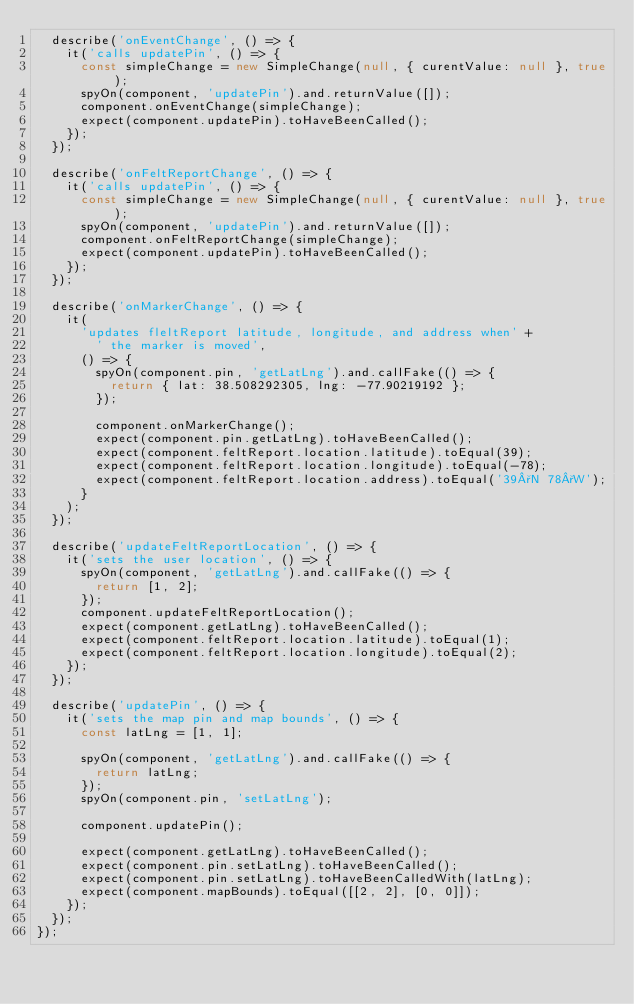Convert code to text. <code><loc_0><loc_0><loc_500><loc_500><_TypeScript_>  describe('onEventChange', () => {
    it('calls updatePin', () => {
      const simpleChange = new SimpleChange(null, { curentValue: null }, true);
      spyOn(component, 'updatePin').and.returnValue([]);
      component.onEventChange(simpleChange);
      expect(component.updatePin).toHaveBeenCalled();
    });
  });

  describe('onFeltReportChange', () => {
    it('calls updatePin', () => {
      const simpleChange = new SimpleChange(null, { curentValue: null }, true);
      spyOn(component, 'updatePin').and.returnValue([]);
      component.onFeltReportChange(simpleChange);
      expect(component.updatePin).toHaveBeenCalled();
    });
  });

  describe('onMarkerChange', () => {
    it(
      'updates fleltReport latitude, longitude, and address when' +
        ' the marker is moved',
      () => {
        spyOn(component.pin, 'getLatLng').and.callFake(() => {
          return { lat: 38.508292305, lng: -77.90219192 };
        });

        component.onMarkerChange();
        expect(component.pin.getLatLng).toHaveBeenCalled();
        expect(component.feltReport.location.latitude).toEqual(39);
        expect(component.feltReport.location.longitude).toEqual(-78);
        expect(component.feltReport.location.address).toEqual('39°N 78°W');
      }
    );
  });

  describe('updateFeltReportLocation', () => {
    it('sets the user location', () => {
      spyOn(component, 'getLatLng').and.callFake(() => {
        return [1, 2];
      });
      component.updateFeltReportLocation();
      expect(component.getLatLng).toHaveBeenCalled();
      expect(component.feltReport.location.latitude).toEqual(1);
      expect(component.feltReport.location.longitude).toEqual(2);
    });
  });

  describe('updatePin', () => {
    it('sets the map pin and map bounds', () => {
      const latLng = [1, 1];

      spyOn(component, 'getLatLng').and.callFake(() => {
        return latLng;
      });
      spyOn(component.pin, 'setLatLng');

      component.updatePin();

      expect(component.getLatLng).toHaveBeenCalled();
      expect(component.pin.setLatLng).toHaveBeenCalled();
      expect(component.pin.setLatLng).toHaveBeenCalledWith(latLng);
      expect(component.mapBounds).toEqual([[2, 2], [0, 0]]);
    });
  });
});
</code> 